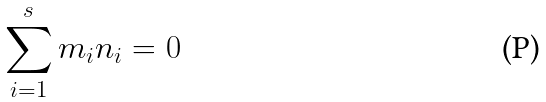<formula> <loc_0><loc_0><loc_500><loc_500>\sum _ { i = 1 } ^ { s } m _ { i } n _ { i } = 0</formula> 